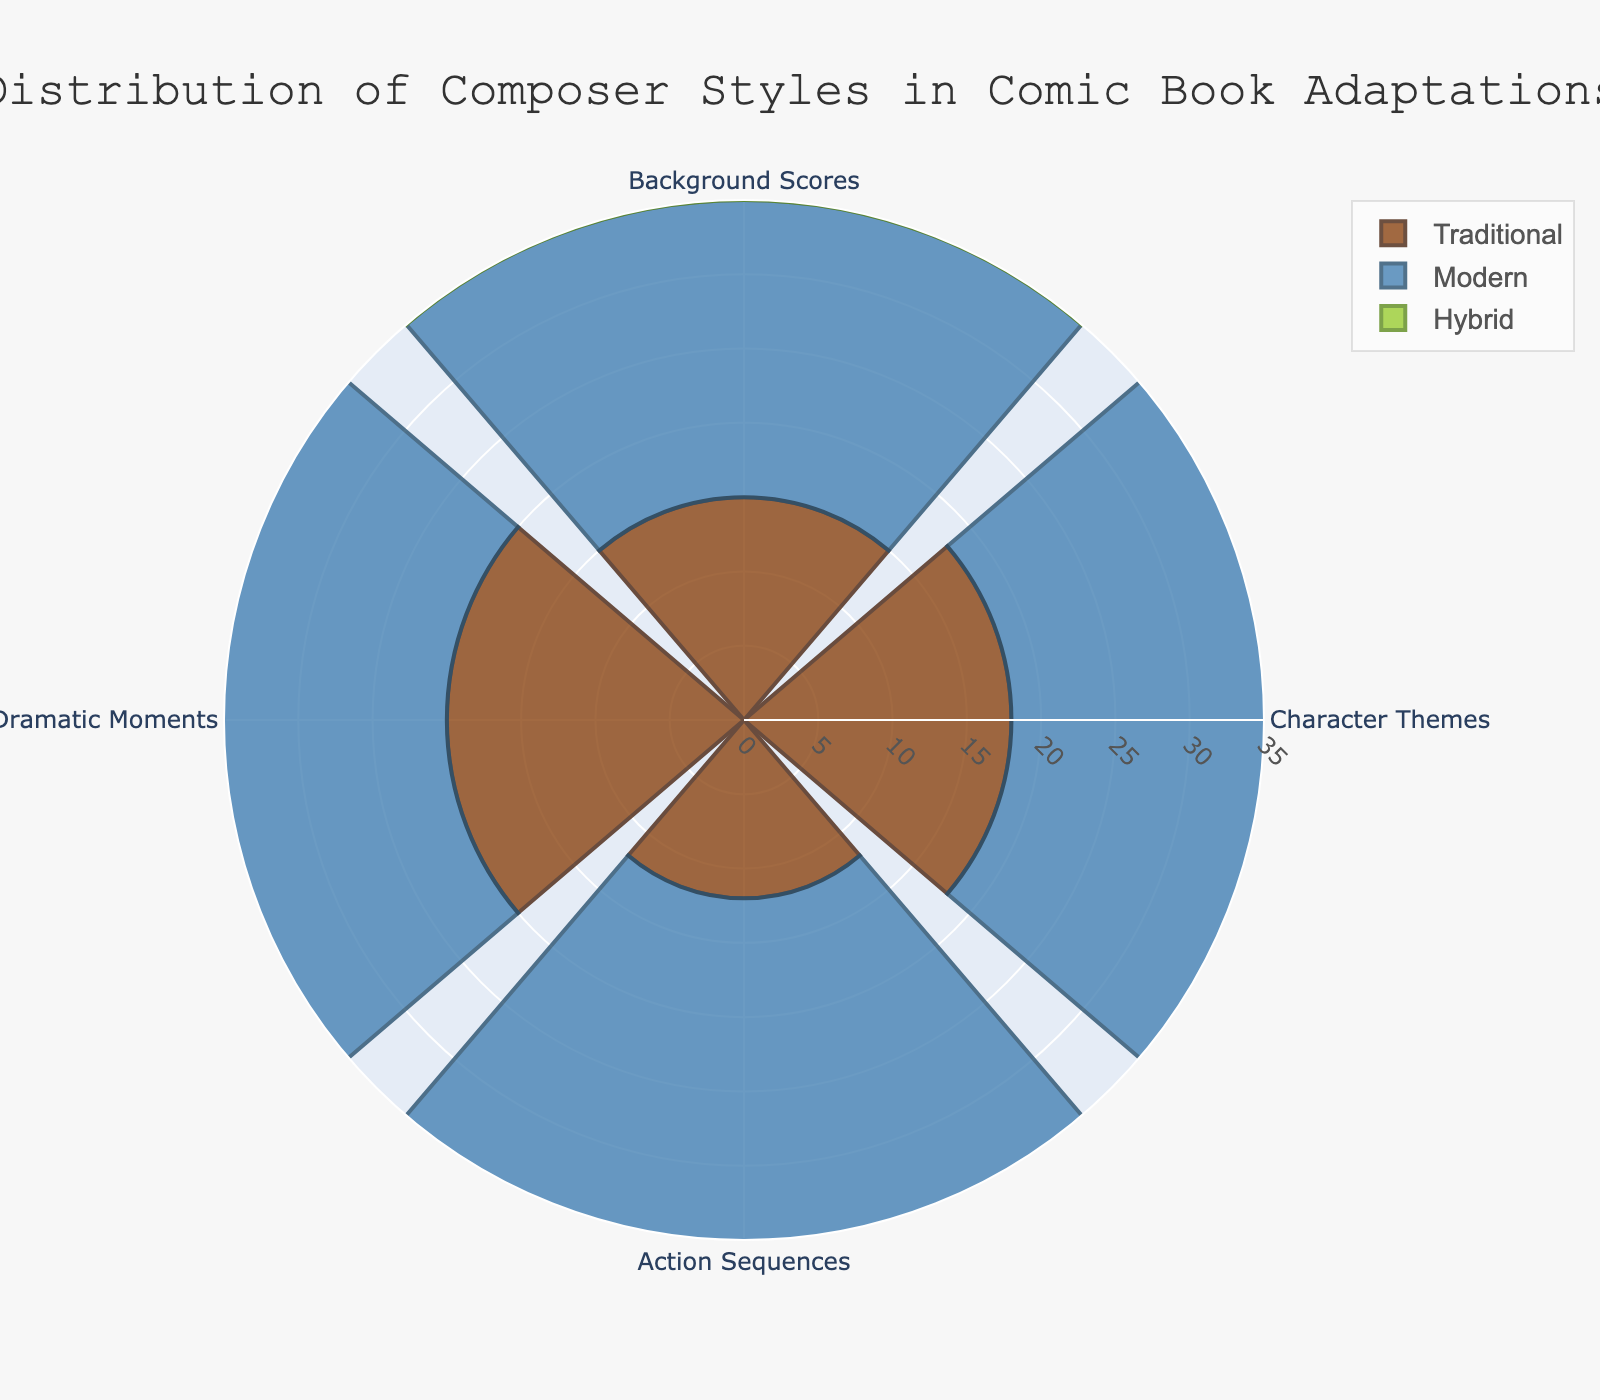What's the most prominent composer style for Action Sequences? Looking at the figure, we see the bar representing 'Modern' for Action Sequences extends further than the other bars.
Answer: Modern Which composer style has the highest value for Dramatic Moments? Observing the figure, the 'Traditional' bar for Dramatic Moments is the longest.
Answer: Traditional Compare the values of Modern and Traditional styles for Character Themes. Which one is higher and by how much? The 'Modern' style has a value of 25 and the 'Traditional' style has a value of 18. The difference is 25 - 18.
Answer: Modern by 7 What is the total combined value of the Hybrid style across all categories? Sum up the values of Hybrid from each category: 10 (Background Scores) + 12 (Character Themes) + 8 (Action Sequences) + 15 (Dramatic Moments). The total is 45.
Answer: 45 Which composer style has the lowest value for Background Scores? The bar for 'Hybrid' in Background Scores is shorter than for the other styles.
Answer: Hybrid How does the value of Modern for Action Sequences compare to the combined value of Traditional and Hybrid for the same category? 'Modern' for Action Sequences is 30, and combined Traditional and Hybrid is 12 (Traditional) + 8 (Hybrid) = 20. The comparison shows 30 is greater than 20.
Answer: Greater by 10 Which category has the smallest difference between Traditional and Hybrid styles? Calculate the differences: 
- Background Scores: 15 - 10 = 5
- Character Themes: 18 - 12 = 6
- Action Sequences: 12 - 8 = 4
- Dramatic Moments: 20 - 15 = 5
The smallest difference is in Action Sequences.
Answer: Action Sequences For which category is the value for the Traditional style closest to its value in Modern? Look at the figure and compare each category: 
- Background Scores: 15 vs 20 (difference: 5)
- Character Themes: 18 vs 25 (difference: 7)
- Action Sequences: 12 vs 30 (difference: 18)
- Dramatic Moments: 20 vs 18 (difference: 2)
The values for Dramatic Moments are closest.
Answer: Dramatic Moments 